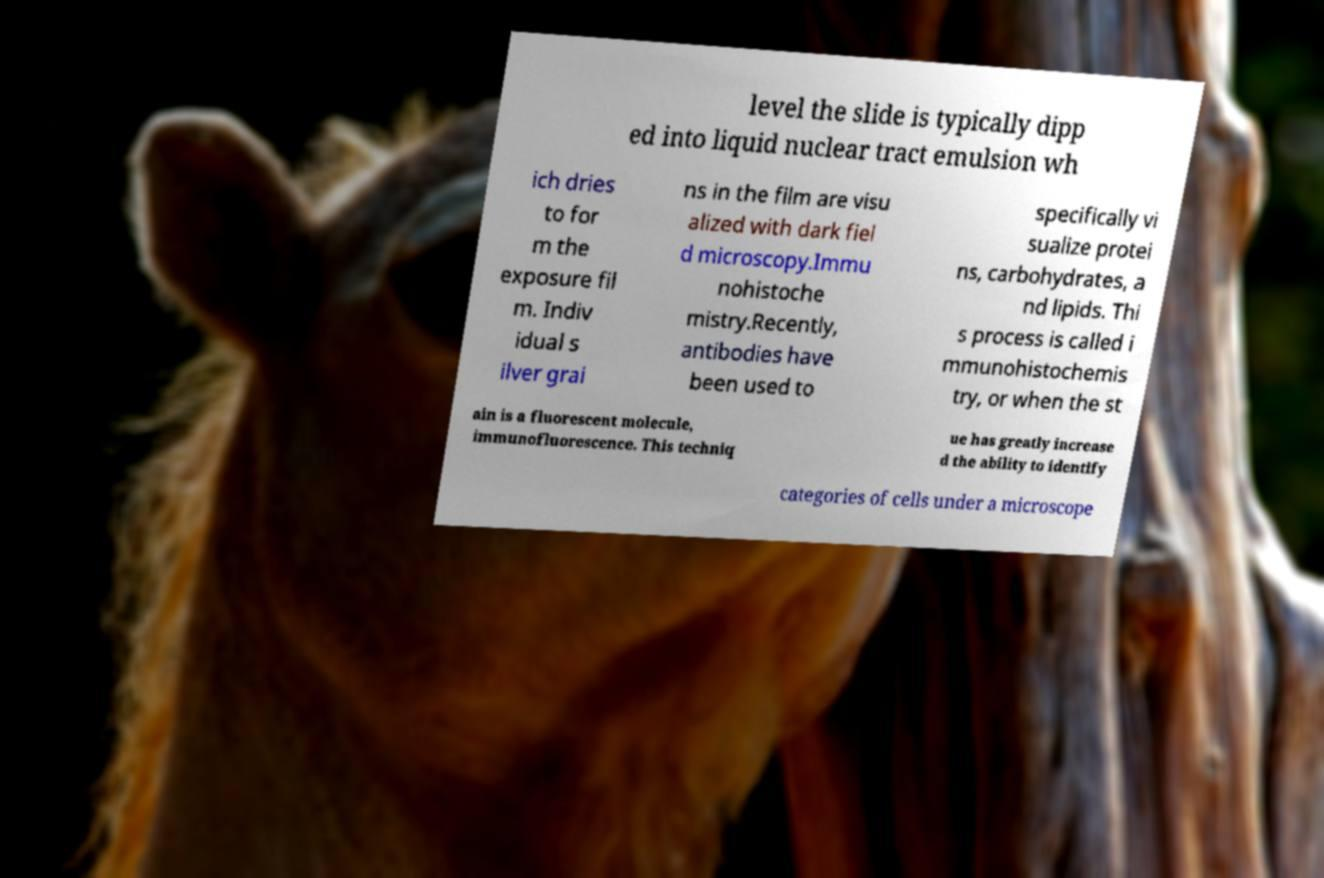Can you accurately transcribe the text from the provided image for me? level the slide is typically dipp ed into liquid nuclear tract emulsion wh ich dries to for m the exposure fil m. Indiv idual s ilver grai ns in the film are visu alized with dark fiel d microscopy.Immu nohistoche mistry.Recently, antibodies have been used to specifically vi sualize protei ns, carbohydrates, a nd lipids. Thi s process is called i mmunohistochemis try, or when the st ain is a fluorescent molecule, immunofluorescence. This techniq ue has greatly increase d the ability to identify categories of cells under a microscope 